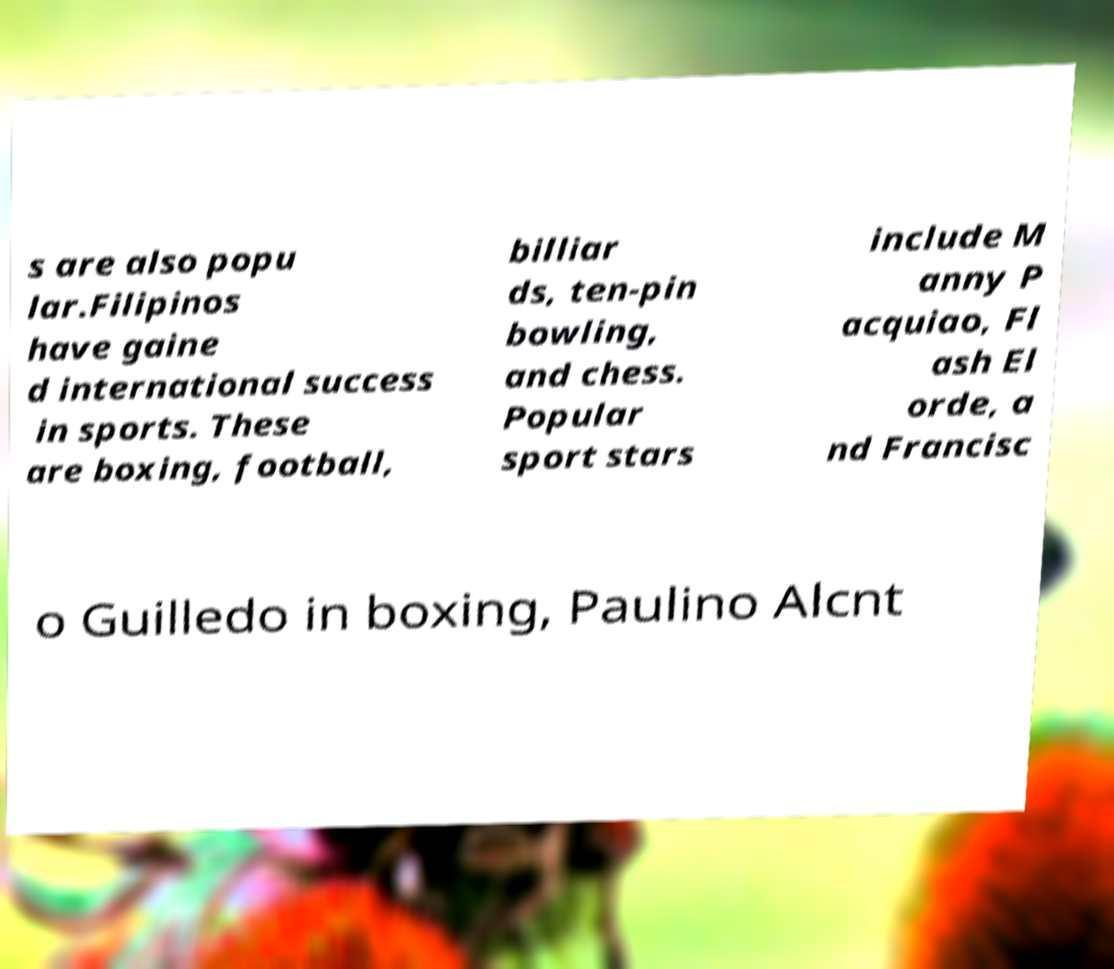What messages or text are displayed in this image? I need them in a readable, typed format. s are also popu lar.Filipinos have gaine d international success in sports. These are boxing, football, billiar ds, ten-pin bowling, and chess. Popular sport stars include M anny P acquiao, Fl ash El orde, a nd Francisc o Guilledo in boxing, Paulino Alcnt 